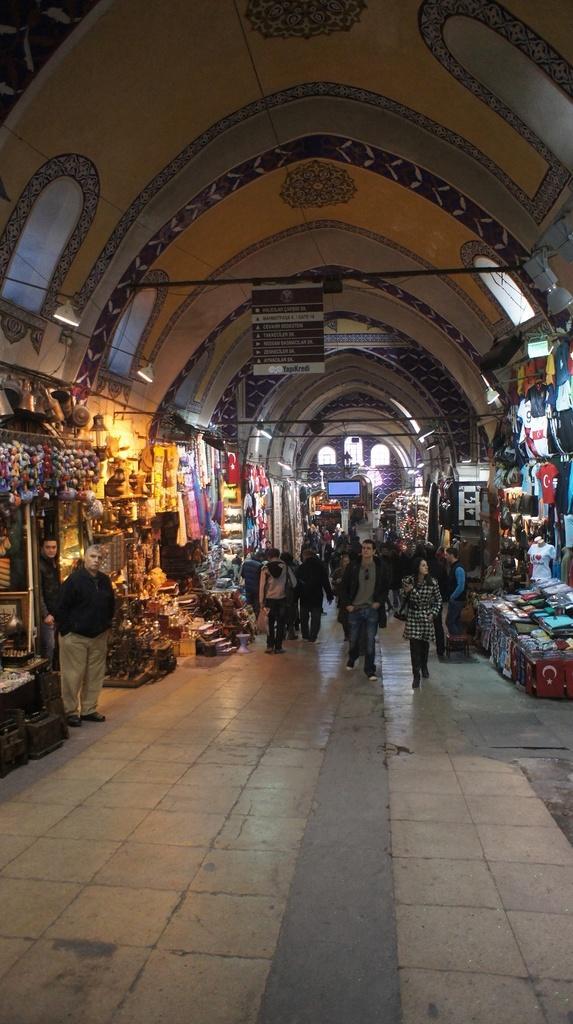Could you give a brief overview of what you see in this image? In this image I can see shops, building, tables, some objects, clothes and a crowd on the road. In the background I can see a rooftop, windows, boards and metal rods. This image is taken may be on the road. 